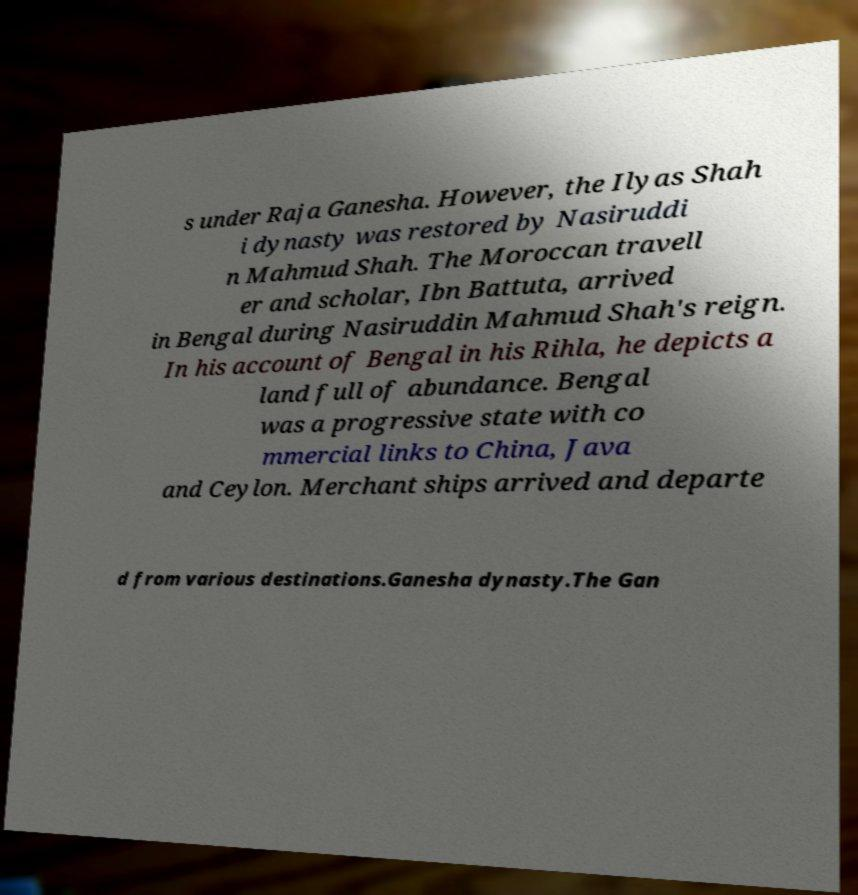For documentation purposes, I need the text within this image transcribed. Could you provide that? s under Raja Ganesha. However, the Ilyas Shah i dynasty was restored by Nasiruddi n Mahmud Shah. The Moroccan travell er and scholar, Ibn Battuta, arrived in Bengal during Nasiruddin Mahmud Shah's reign. In his account of Bengal in his Rihla, he depicts a land full of abundance. Bengal was a progressive state with co mmercial links to China, Java and Ceylon. Merchant ships arrived and departe d from various destinations.Ganesha dynasty.The Gan 